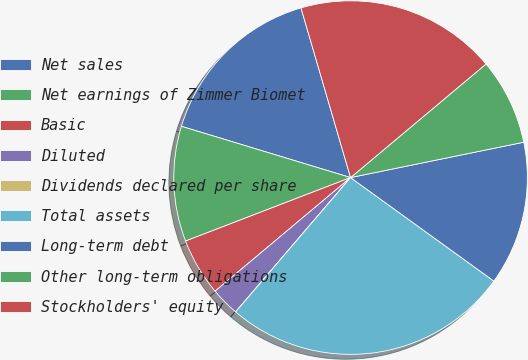Convert chart to OTSL. <chart><loc_0><loc_0><loc_500><loc_500><pie_chart><fcel>Net sales<fcel>Net earnings of Zimmer Biomet<fcel>Basic<fcel>Diluted<fcel>Dividends declared per share<fcel>Total assets<fcel>Long-term debt<fcel>Other long-term obligations<fcel>Stockholders' equity<nl><fcel>15.79%<fcel>10.53%<fcel>5.26%<fcel>2.63%<fcel>0.0%<fcel>26.31%<fcel>13.16%<fcel>7.9%<fcel>18.42%<nl></chart> 